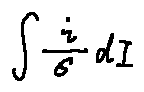<formula> <loc_0><loc_0><loc_500><loc_500>\int \frac { i } { \sigma } d I</formula> 